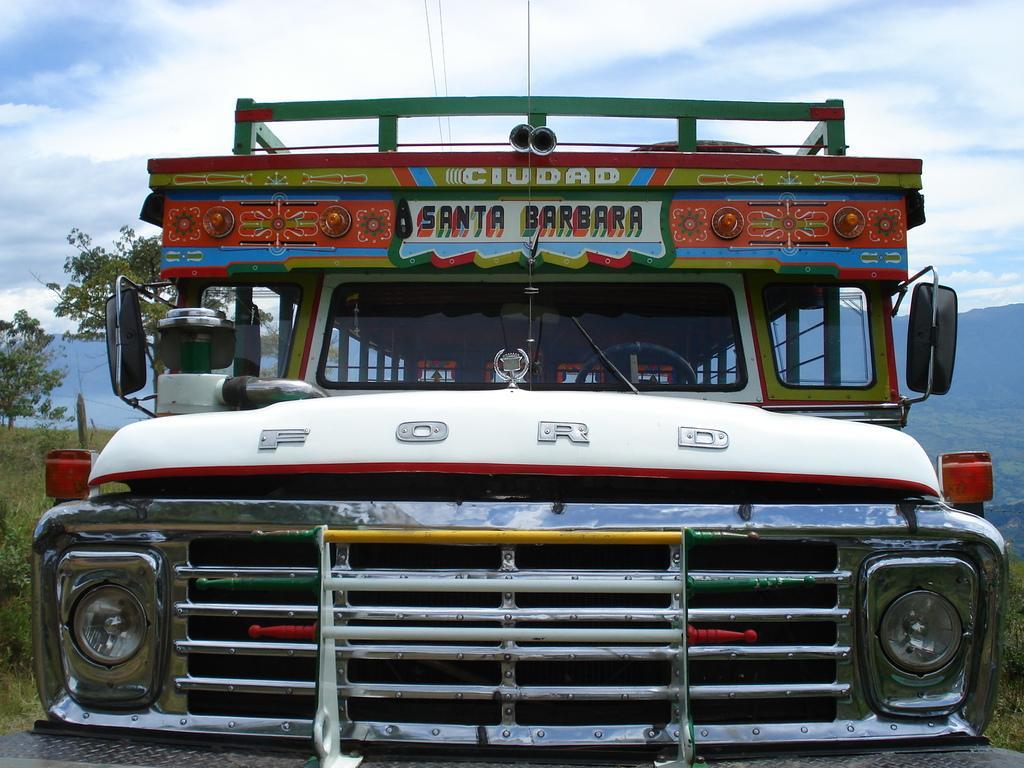Please provide a concise description of this image. In this picture we can see vehicle, grass and trees. In the background of the image we can see hills and sky with clouds. 